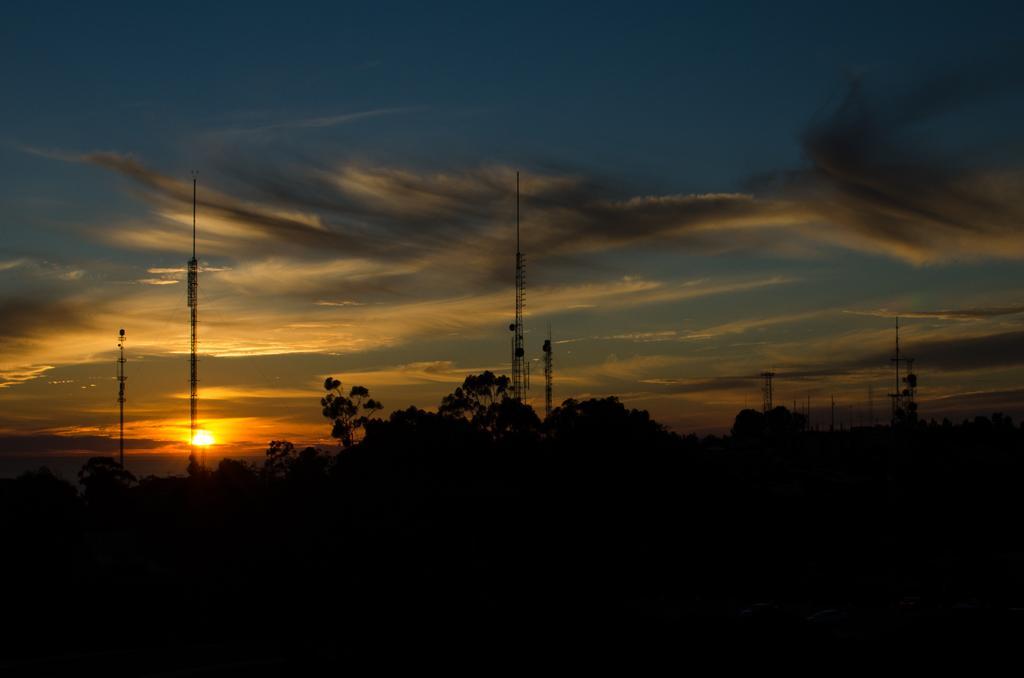Describe this image in one or two sentences. In this picture there are trees and poles in the center of the image and there is sky at the top side of the image, it seems to be the view of sunset. 